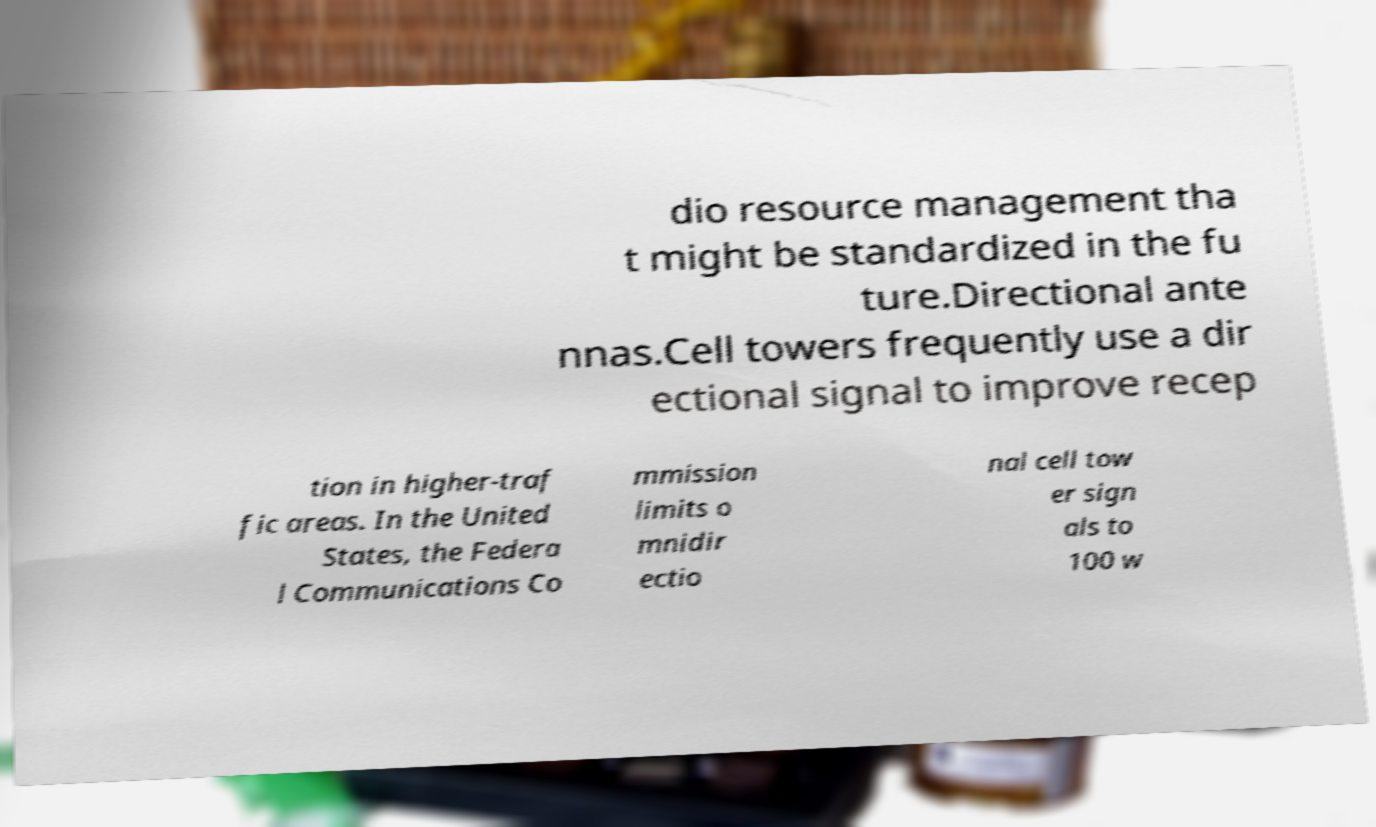Can you read and provide the text displayed in the image?This photo seems to have some interesting text. Can you extract and type it out for me? dio resource management tha t might be standardized in the fu ture.Directional ante nnas.Cell towers frequently use a dir ectional signal to improve recep tion in higher-traf fic areas. In the United States, the Federa l Communications Co mmission limits o mnidir ectio nal cell tow er sign als to 100 w 